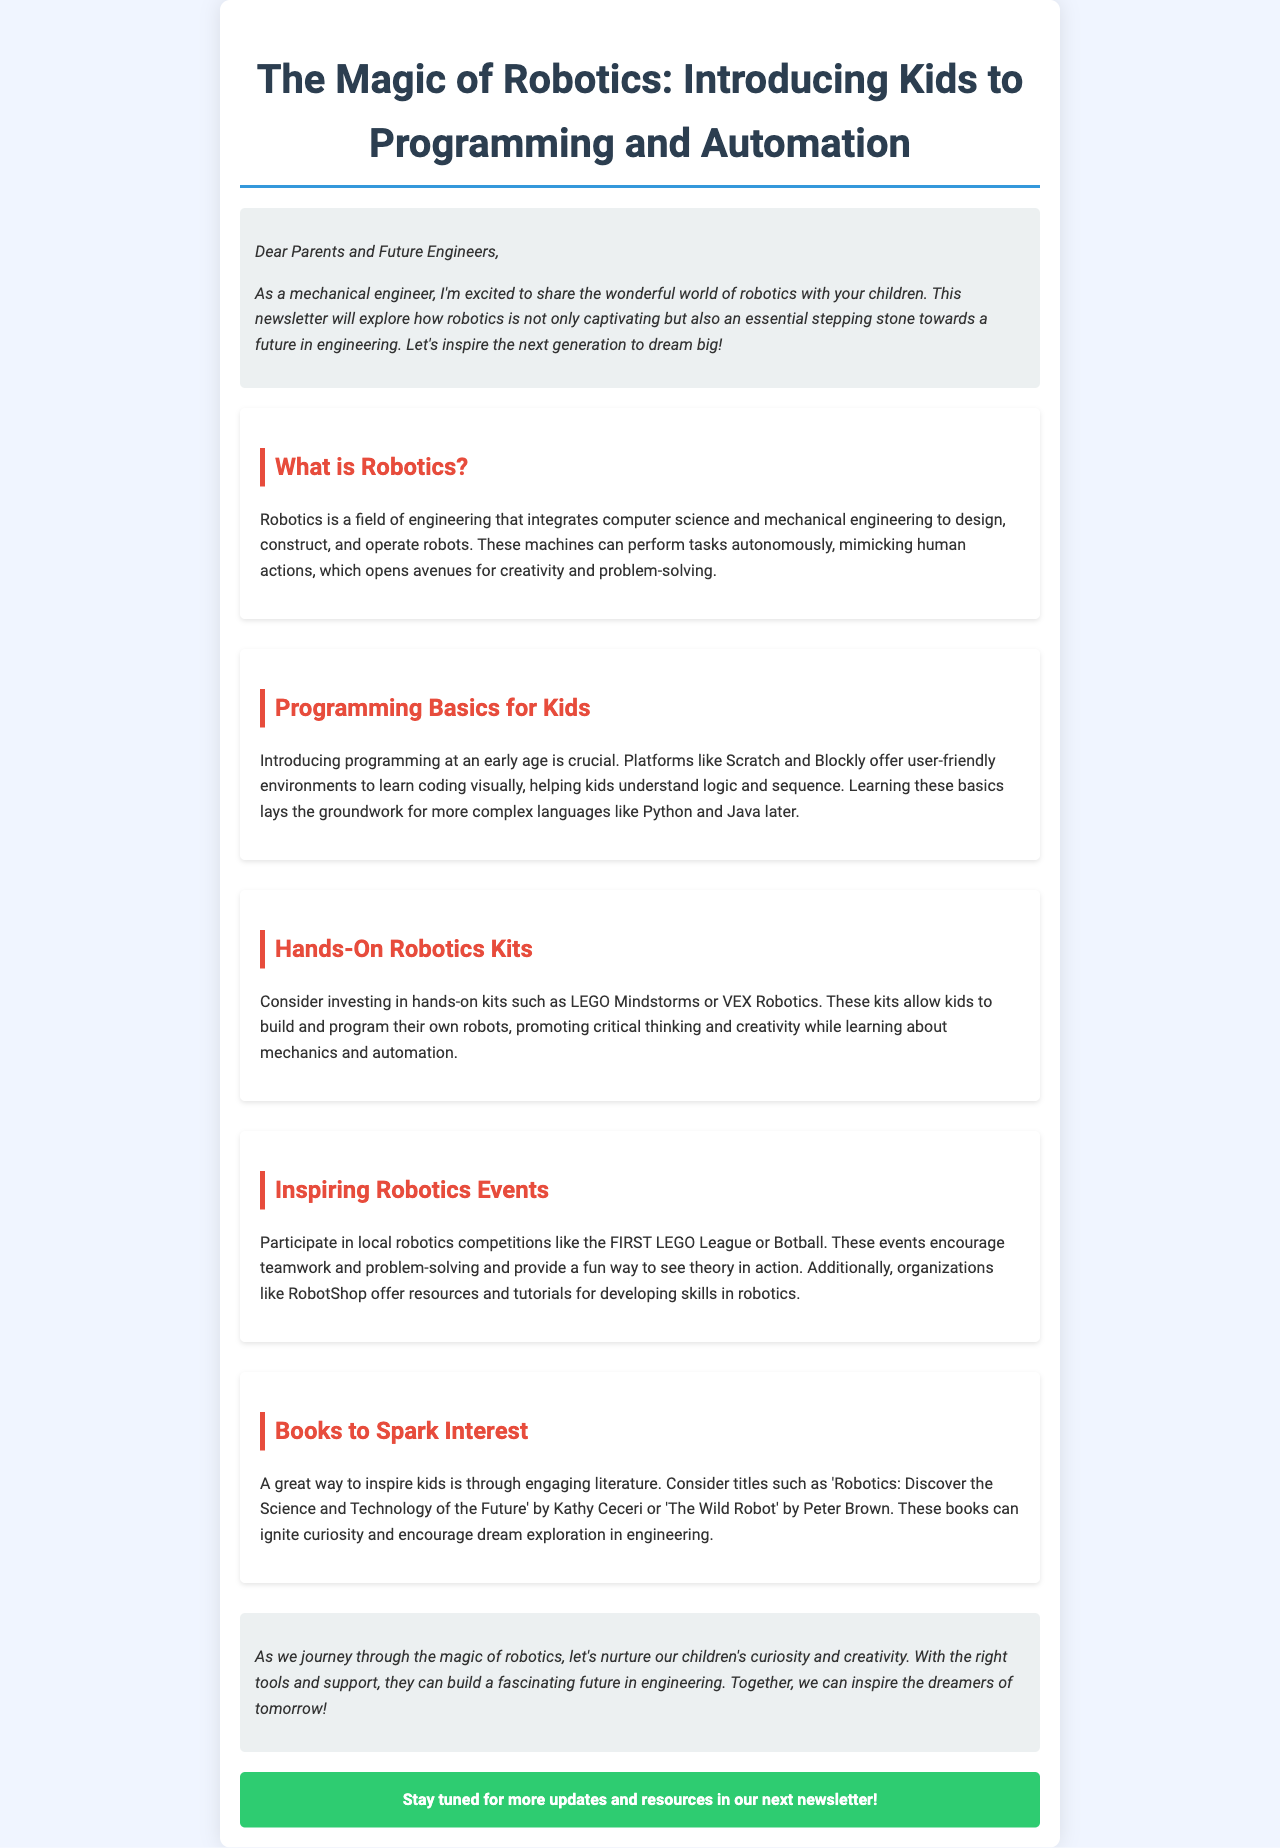What is robotics? Robotics is defined in the document as a field of engineering that integrates computer science and mechanical engineering to design, construct, and operate robots.
Answer: A field of engineering What are some programming platforms for kids? The document mentions Scratch and Blockly as user-friendly environments for kids to learn programming.
Answer: Scratch and Blockly What is one recommended robotics kit? The document suggests investing in LEGO Mindstorms as a hands-on robotics kit for kids.
Answer: LEGO Mindstorms Name a local robotics competition mentioned. The document refers to the FIRST LEGO League as a local robotics competition to participate in.
Answer: FIRST LEGO League Which book is suggested to spark interest in robotics? The document recommends the book 'Robotics: Discover the Science and Technology of the Future' by Kathy Ceceri to inspire kids.
Answer: 'Robotics: Discover the Science and Technology of the Future' What do robotics events encourage? According to the document, robotics events encourage teamwork and problem-solving among participants.
Answer: Teamwork and problem-solving Who is the target audience of this newsletter? The newsletter is aimed at parents and future engineers who want to inspire children in engineering.
Answer: Parents and Future Engineers What is the purpose of introducing programming early? The document states that introducing programming at an early age is crucial for helping kids understand logic and sequence.
Answer: Understanding logic and sequence 